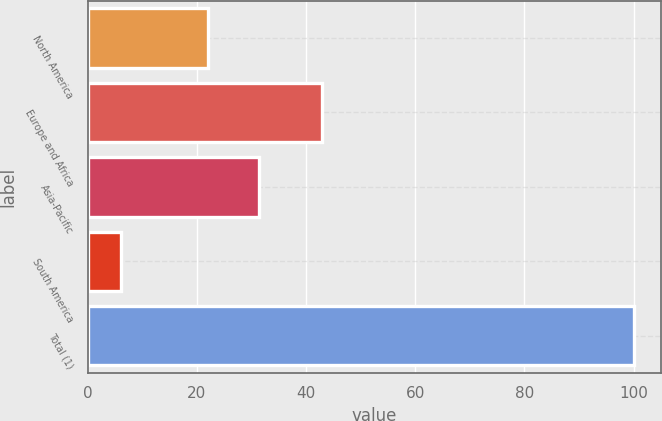Convert chart to OTSL. <chart><loc_0><loc_0><loc_500><loc_500><bar_chart><fcel>North America<fcel>Europe and Africa<fcel>Asia-Pacific<fcel>South America<fcel>Total (1)<nl><fcel>22<fcel>43<fcel>31.4<fcel>6<fcel>100<nl></chart> 